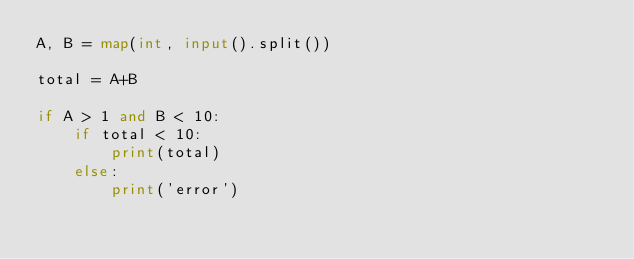Convert code to text. <code><loc_0><loc_0><loc_500><loc_500><_Python_>A, B = map(int, input().split())

total = A+B

if A > 1 and B < 10:
    if total < 10:
        print(total)
    else:
        print('error')</code> 